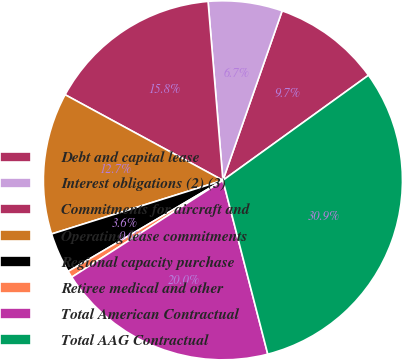Convert chart to OTSL. <chart><loc_0><loc_0><loc_500><loc_500><pie_chart><fcel>Debt and capital lease<fcel>Interest obligations (2) (3)<fcel>Commitments for aircraft and<fcel>Operating lease commitments<fcel>Regional capacity purchase<fcel>Retiree medical and other<fcel>Total American Contractual<fcel>Total AAG Contractual<nl><fcel>9.7%<fcel>6.67%<fcel>15.77%<fcel>12.74%<fcel>3.64%<fcel>0.6%<fcel>19.95%<fcel>30.93%<nl></chart> 